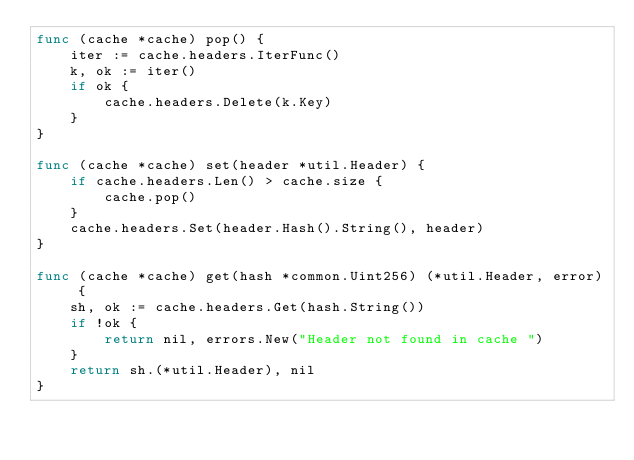<code> <loc_0><loc_0><loc_500><loc_500><_Go_>func (cache *cache) pop() {
	iter := cache.headers.IterFunc()
	k, ok := iter()
	if ok {
		cache.headers.Delete(k.Key)
	}
}

func (cache *cache) set(header *util.Header) {
	if cache.headers.Len() > cache.size {
		cache.pop()
	}
	cache.headers.Set(header.Hash().String(), header)
}

func (cache *cache) get(hash *common.Uint256) (*util.Header, error) {
	sh, ok := cache.headers.Get(hash.String())
	if !ok {
		return nil, errors.New("Header not found in cache ")
	}
	return sh.(*util.Header), nil
}
</code> 